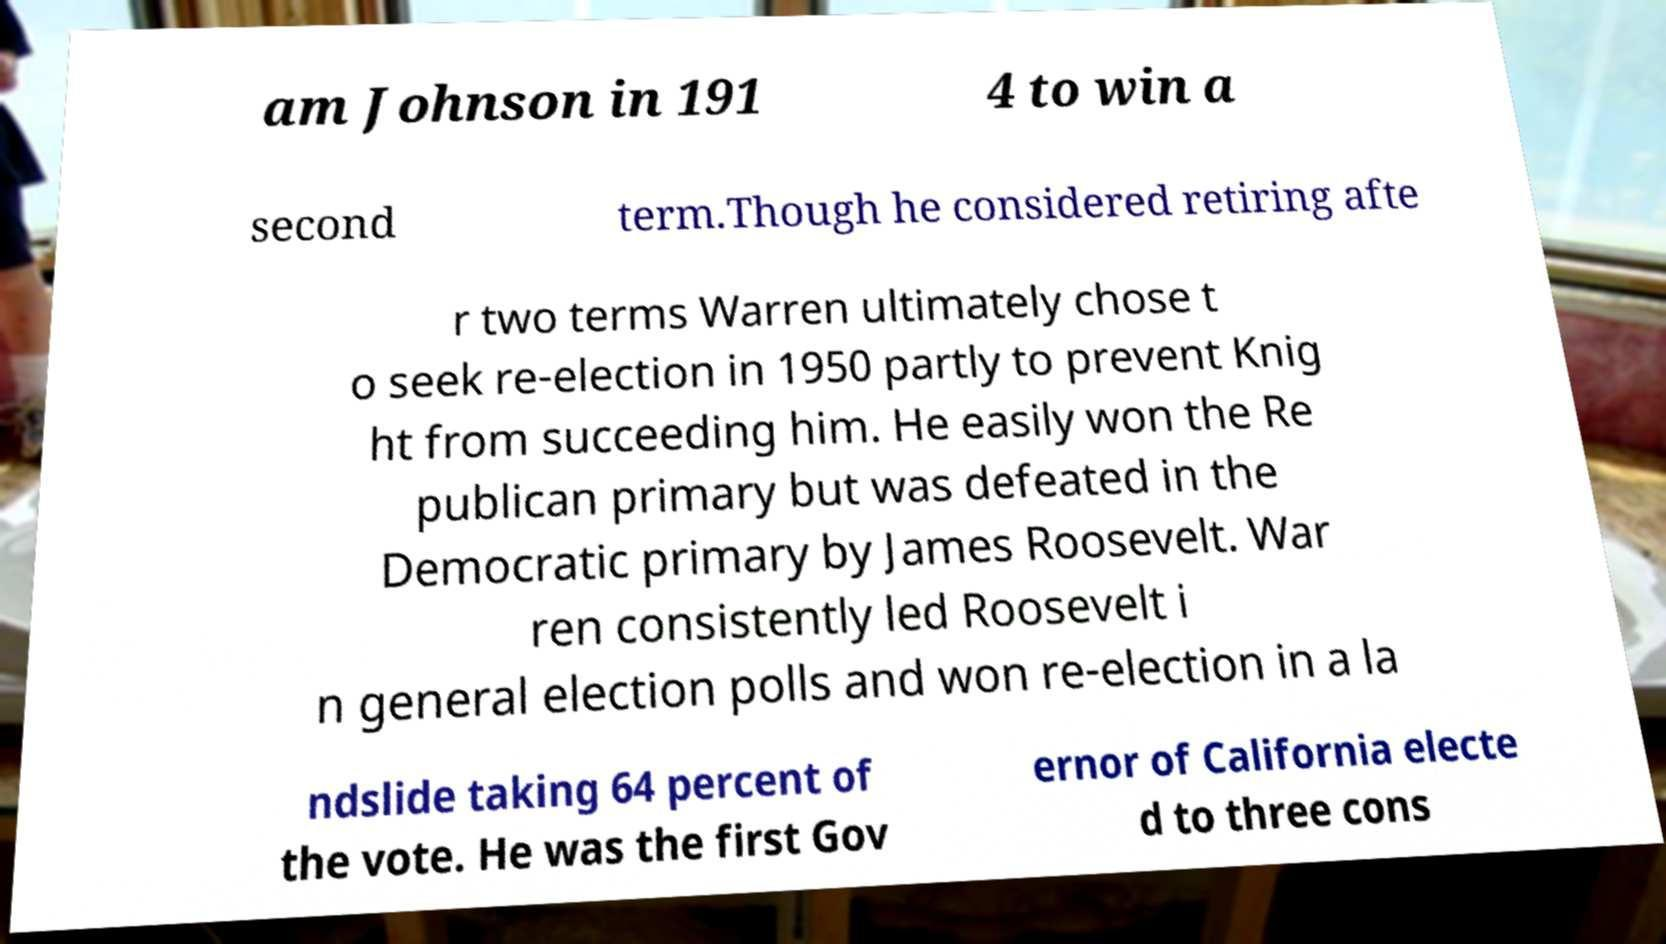Can you read and provide the text displayed in the image?This photo seems to have some interesting text. Can you extract and type it out for me? am Johnson in 191 4 to win a second term.Though he considered retiring afte r two terms Warren ultimately chose t o seek re-election in 1950 partly to prevent Knig ht from succeeding him. He easily won the Re publican primary but was defeated in the Democratic primary by James Roosevelt. War ren consistently led Roosevelt i n general election polls and won re-election in a la ndslide taking 64 percent of the vote. He was the first Gov ernor of California electe d to three cons 